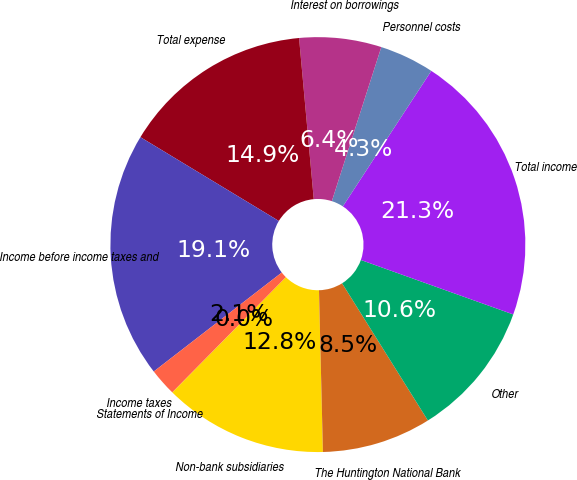<chart> <loc_0><loc_0><loc_500><loc_500><pie_chart><fcel>Statements of Income<fcel>Non-bank subsidiaries<fcel>The Huntington National Bank<fcel>Other<fcel>Total income<fcel>Personnel costs<fcel>Interest on borrowings<fcel>Total expense<fcel>Income before income taxes and<fcel>Income taxes<nl><fcel>0.01%<fcel>12.76%<fcel>8.51%<fcel>10.64%<fcel>21.26%<fcel>4.26%<fcel>6.39%<fcel>14.89%<fcel>19.14%<fcel>2.14%<nl></chart> 